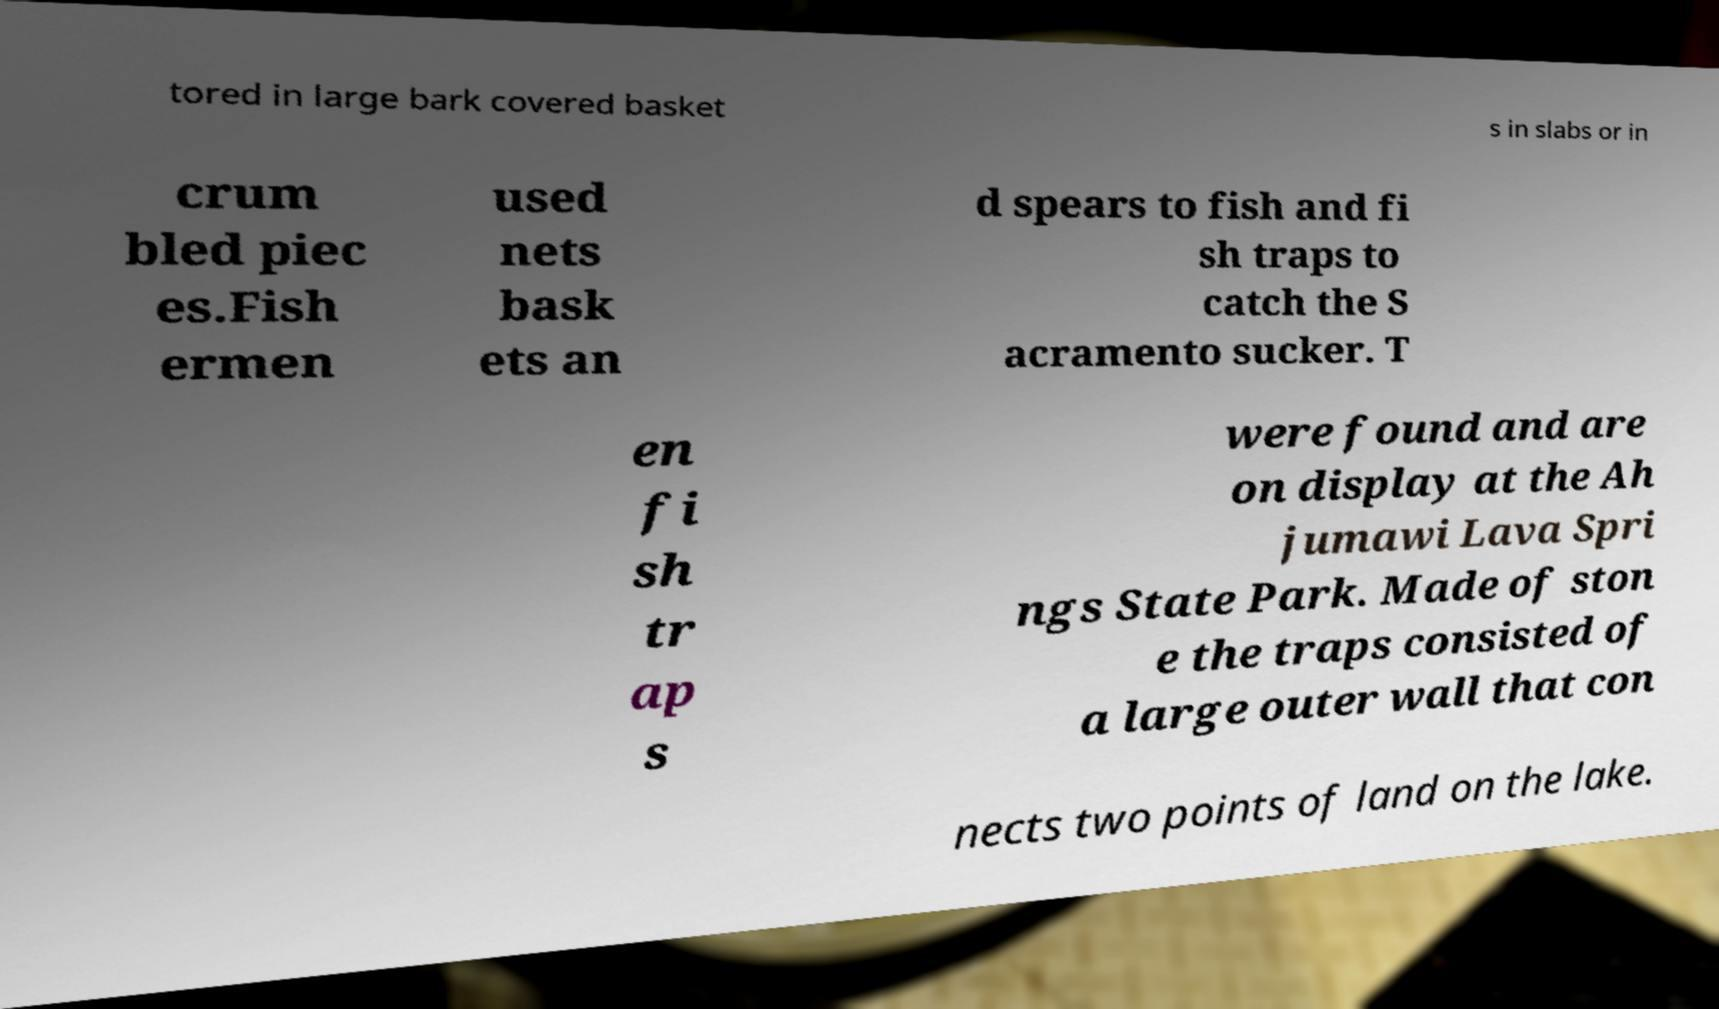Can you accurately transcribe the text from the provided image for me? tored in large bark covered basket s in slabs or in crum bled piec es.Fish ermen used nets bask ets an d spears to fish and fi sh traps to catch the S acramento sucker. T en fi sh tr ap s were found and are on display at the Ah jumawi Lava Spri ngs State Park. Made of ston e the traps consisted of a large outer wall that con nects two points of land on the lake. 